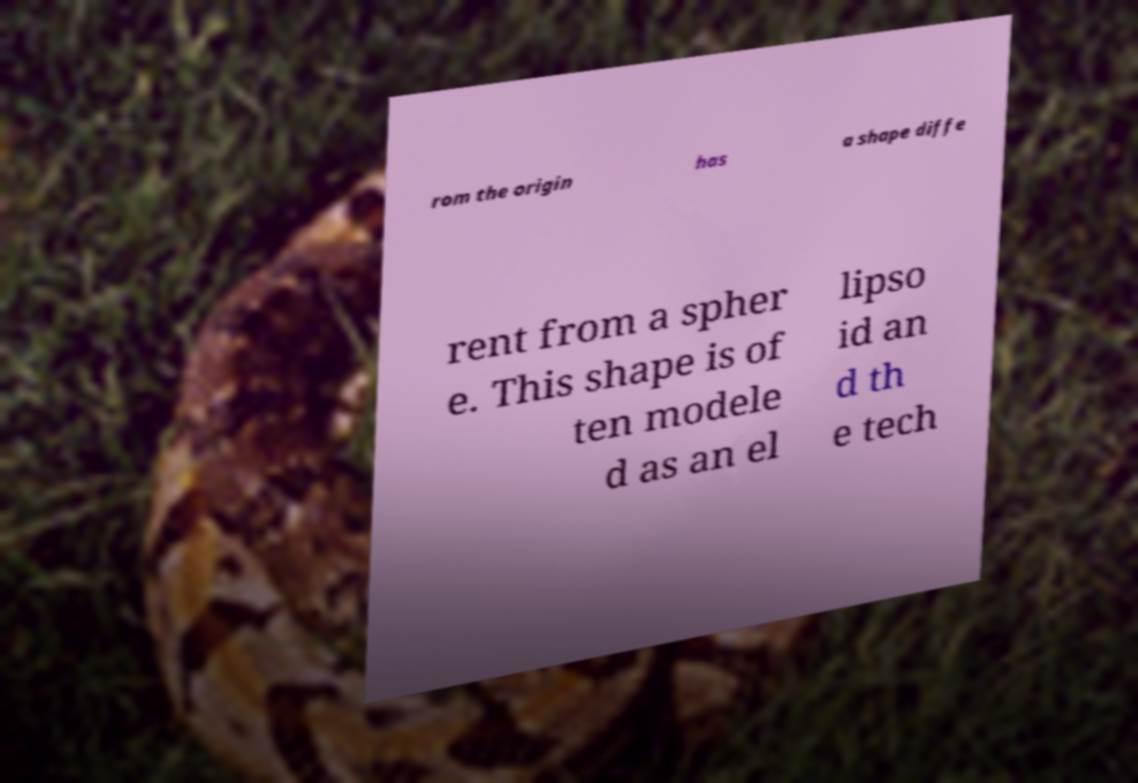Can you read and provide the text displayed in the image?This photo seems to have some interesting text. Can you extract and type it out for me? rom the origin has a shape diffe rent from a spher e. This shape is of ten modele d as an el lipso id an d th e tech 